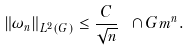<formula> <loc_0><loc_0><loc_500><loc_500>\| \omega _ { n } \| _ { L ^ { 2 } ( G ) } \leq \frac { C } { \sqrt { n } } \ \cap G m ^ { n } .</formula> 